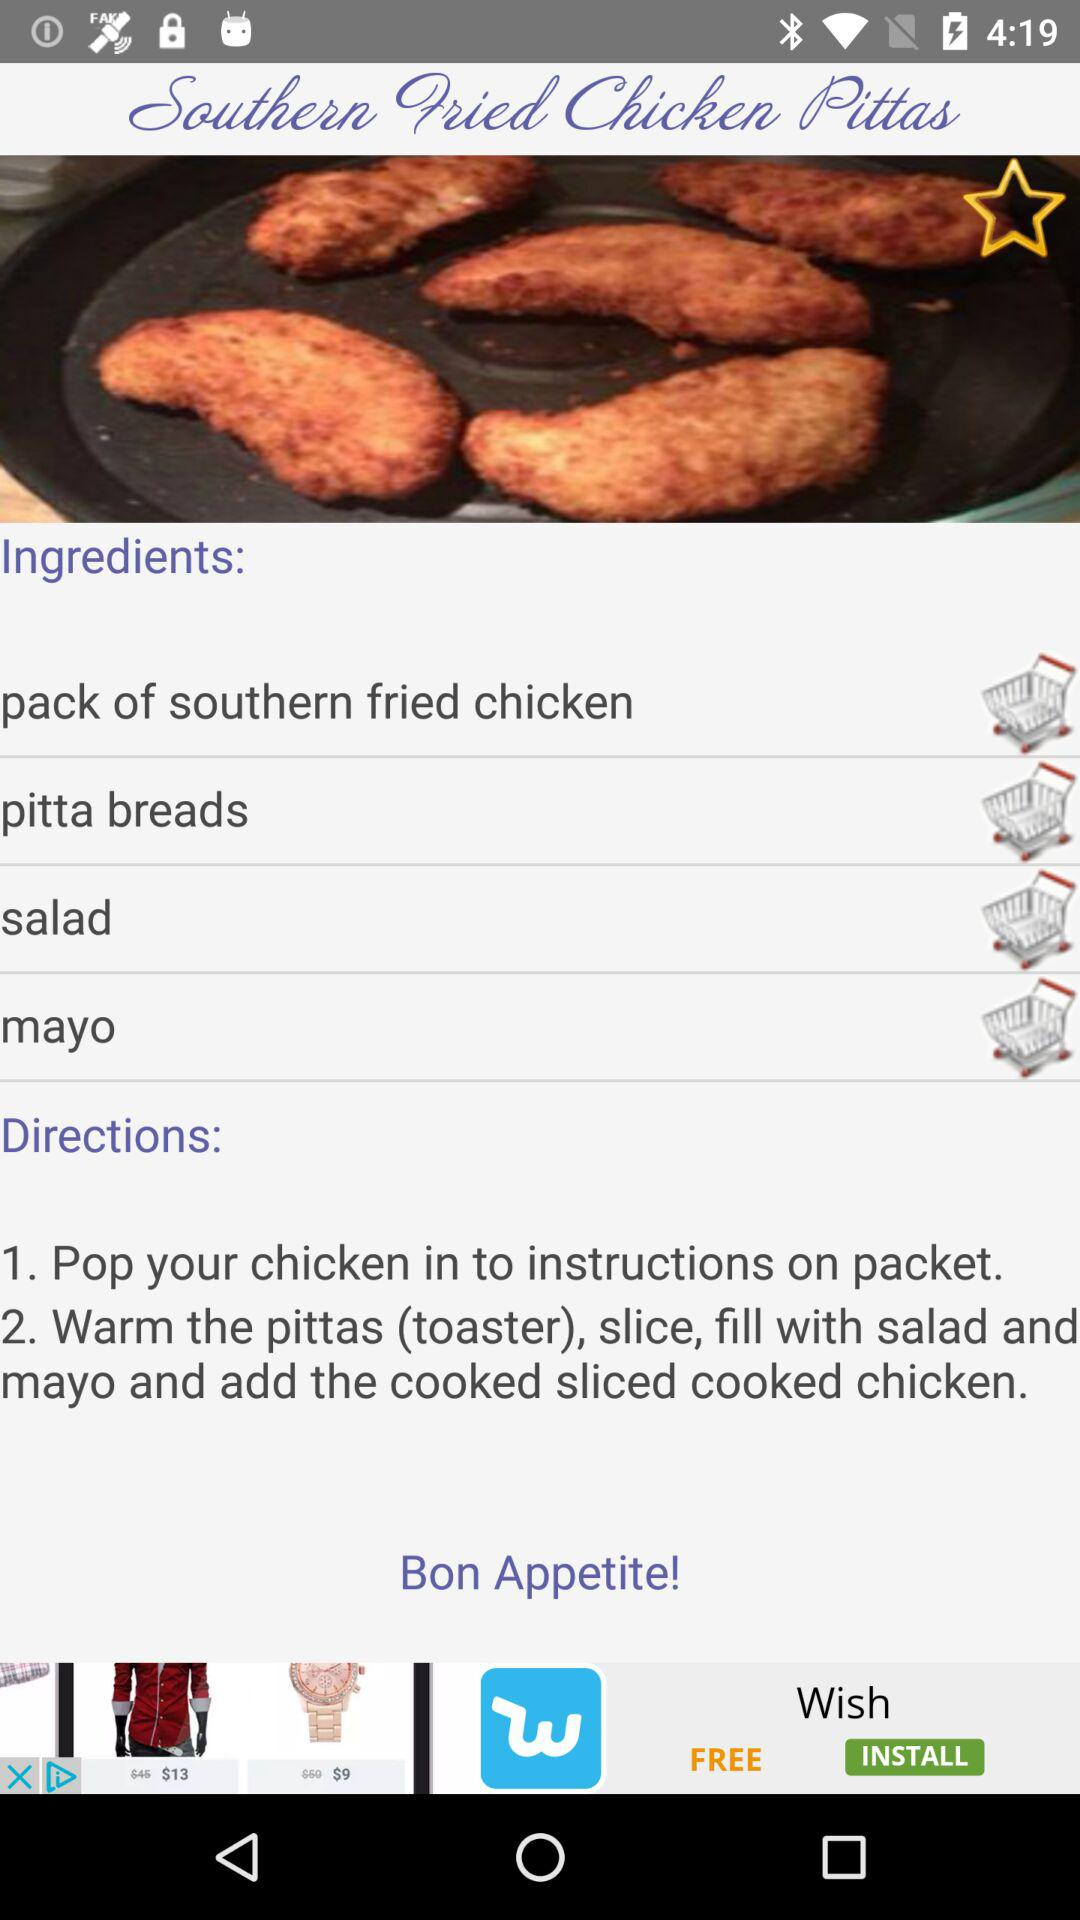What are the ingredients for the dish? The ingredients for the dish are pack of southern fried chicken, pitta breads, salad and mayo. 